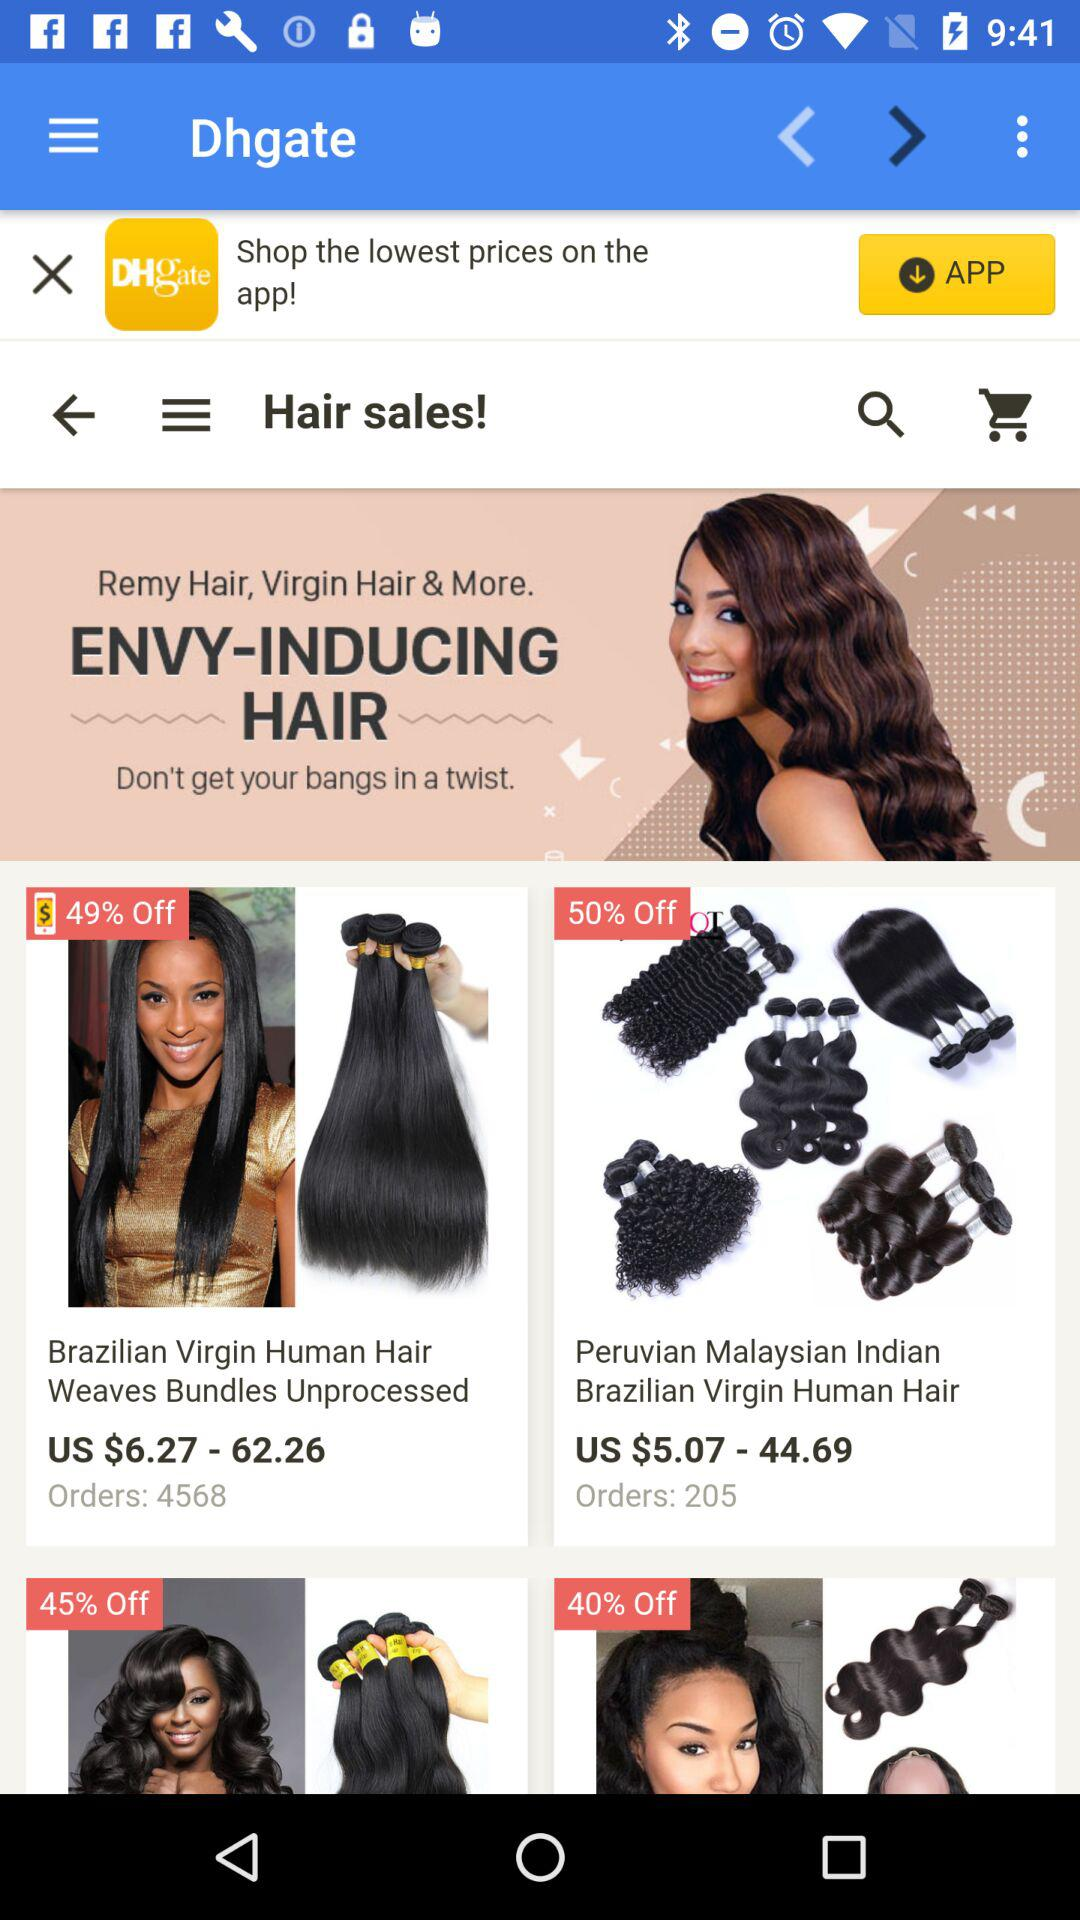How many orders are available for "Brazilian Virgin Human Hair Weaves Bundles Unprocessed"? The available orders are 4568. 